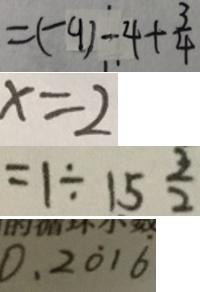<formula> <loc_0><loc_0><loc_500><loc_500>= ( - 9 ) - 4 + \frac { 3 } { 4 } 
 x = 2 
 = 1 \div 1 5 \frac { 3 } { 2 } 
 0 . 2 \dot { 0 } 1 \dot { 6 }</formula> 